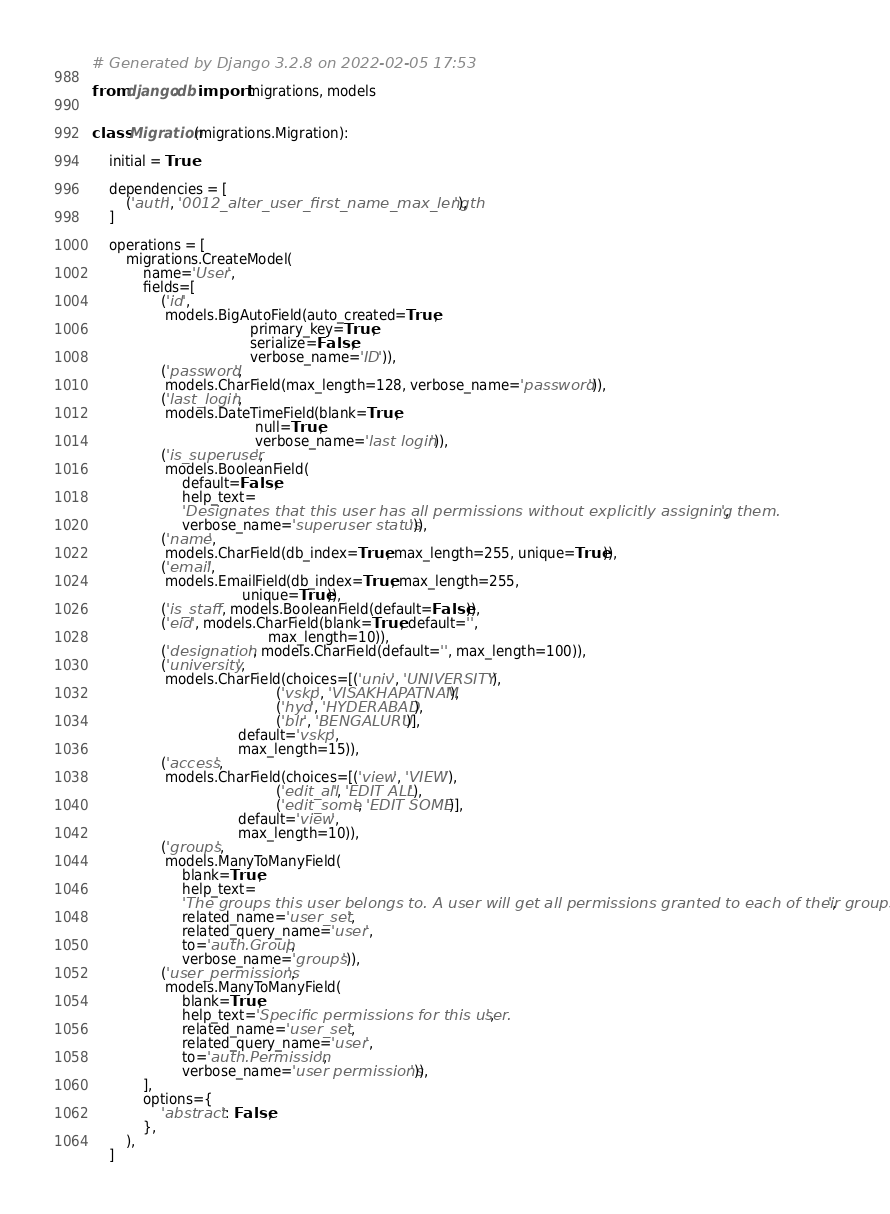Convert code to text. <code><loc_0><loc_0><loc_500><loc_500><_Python_># Generated by Django 3.2.8 on 2022-02-05 17:53

from django.db import migrations, models


class Migration(migrations.Migration):

    initial = True

    dependencies = [
        ('auth', '0012_alter_user_first_name_max_length'),
    ]

    operations = [
        migrations.CreateModel(
            name='User',
            fields=[
                ('id',
                 models.BigAutoField(auto_created=True,
                                     primary_key=True,
                                     serialize=False,
                                     verbose_name='ID')),
                ('password',
                 models.CharField(max_length=128, verbose_name='password')),
                ('last_login',
                 models.DateTimeField(blank=True,
                                      null=True,
                                      verbose_name='last login')),
                ('is_superuser',
                 models.BooleanField(
                     default=False,
                     help_text=
                     'Designates that this user has all permissions without explicitly assigning them.',
                     verbose_name='superuser status')),
                ('name',
                 models.CharField(db_index=True, max_length=255, unique=True)),
                ('email',
                 models.EmailField(db_index=True, max_length=255,
                                   unique=True)),
                ('is_staff', models.BooleanField(default=False)),
                ('eid', models.CharField(blank=True, default='',
                                         max_length=10)),
                ('designation', models.CharField(default='', max_length=100)),
                ('university',
                 models.CharField(choices=[('univ', 'UNIVERSITY'),
                                           ('vskp', 'VISAKHAPATNAM'),
                                           ('hyd', 'HYDERABAD'),
                                           ('blr', 'BENGALURU')],
                                  default='vskp',
                                  max_length=15)),
                ('access',
                 models.CharField(choices=[('view', 'VIEW'),
                                           ('edit_all', 'EDIT ALL'),
                                           ('edit_some', 'EDIT SOME')],
                                  default='view',
                                  max_length=10)),
                ('groups',
                 models.ManyToManyField(
                     blank=True,
                     help_text=
                     'The groups this user belongs to. A user will get all permissions granted to each of their groups.',
                     related_name='user_set',
                     related_query_name='user',
                     to='auth.Group',
                     verbose_name='groups')),
                ('user_permissions',
                 models.ManyToManyField(
                     blank=True,
                     help_text='Specific permissions for this user.',
                     related_name='user_set',
                     related_query_name='user',
                     to='auth.Permission',
                     verbose_name='user permissions')),
            ],
            options={
                'abstract': False,
            },
        ),
    ]
</code> 